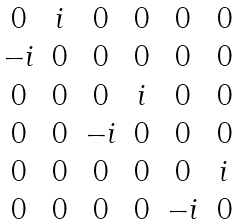<formula> <loc_0><loc_0><loc_500><loc_500>\begin{matrix} 0 & i & 0 & 0 & 0 & 0 \\ - i & 0 & 0 & 0 & 0 & 0 \\ 0 & 0 & 0 & i & 0 & 0 \\ 0 & 0 & - i & 0 & 0 & 0 \\ 0 & 0 & 0 & 0 & 0 & i \\ 0 & 0 & 0 & 0 & - i & 0 \end{matrix}</formula> 